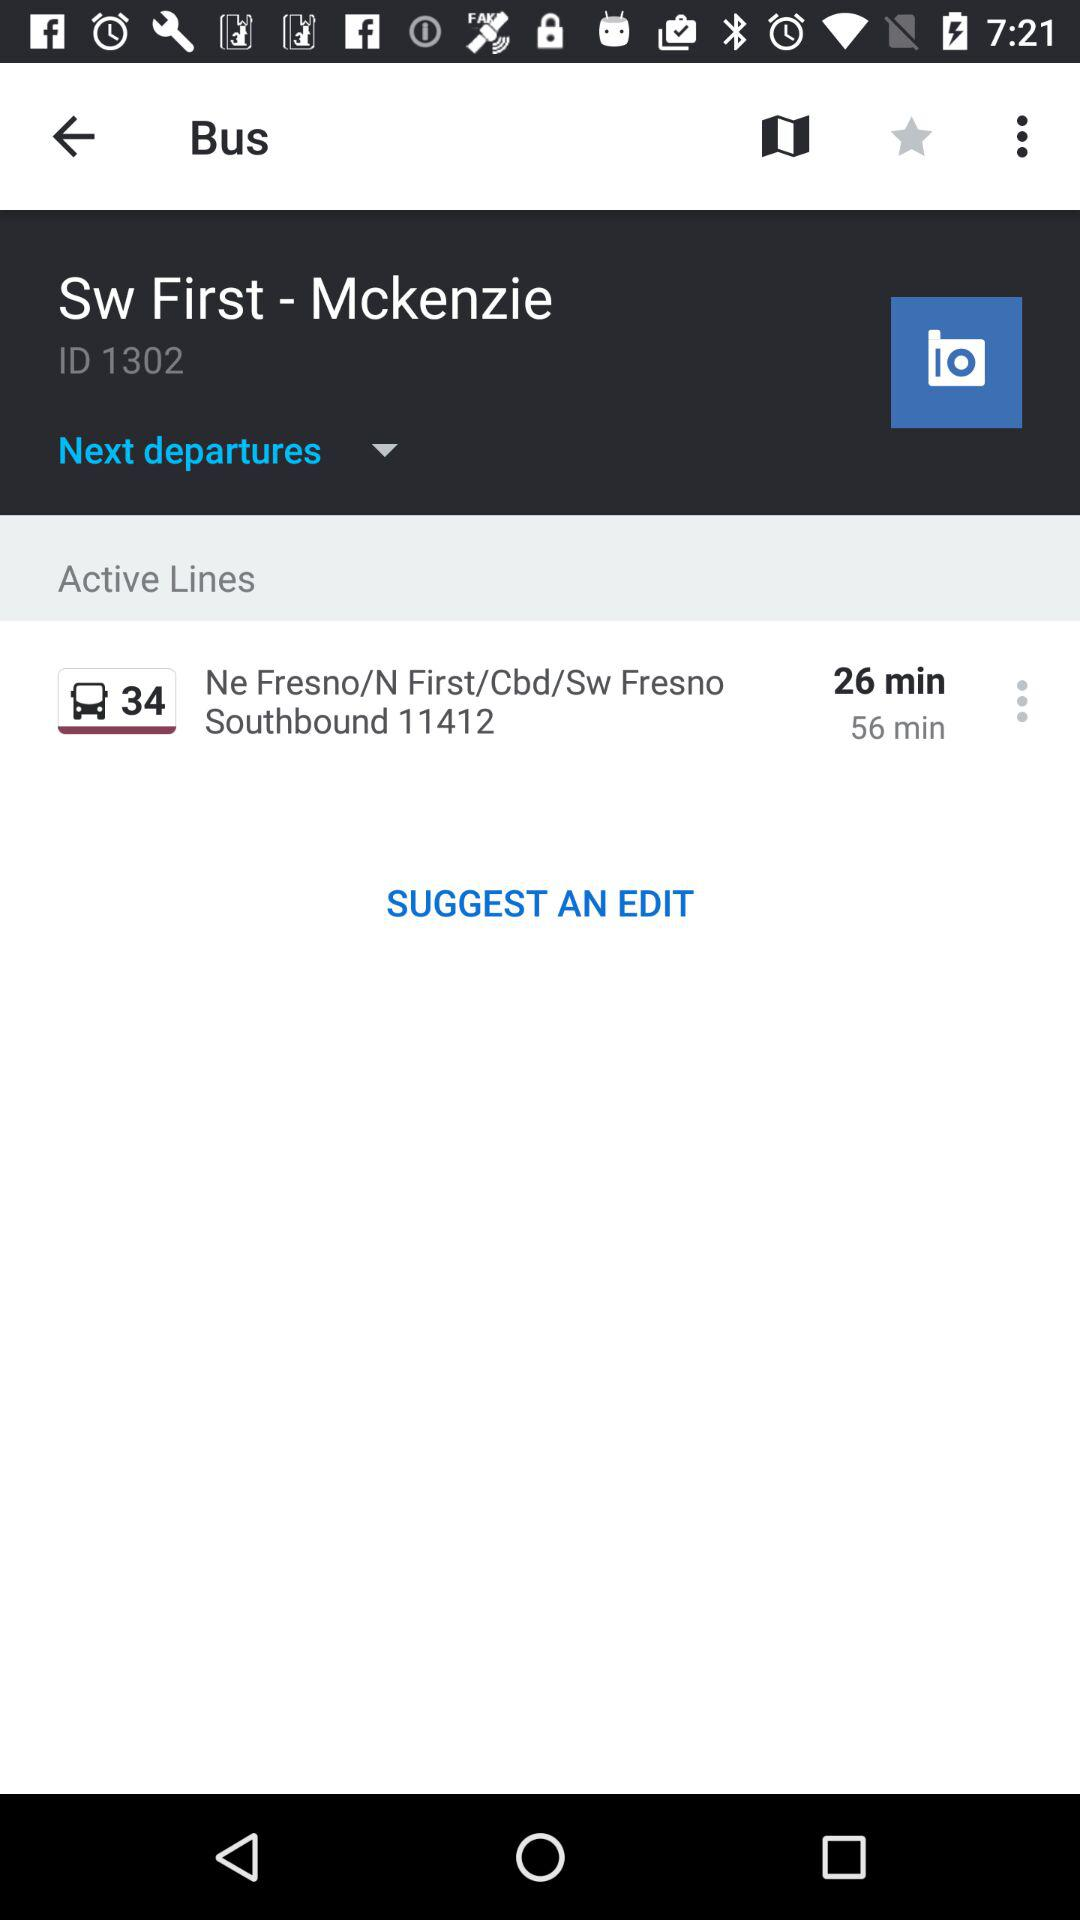What is the ID? The ID is 1302. 